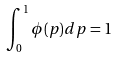<formula> <loc_0><loc_0><loc_500><loc_500>\int _ { 0 } ^ { 1 } \phi ( p ) d p = 1</formula> 